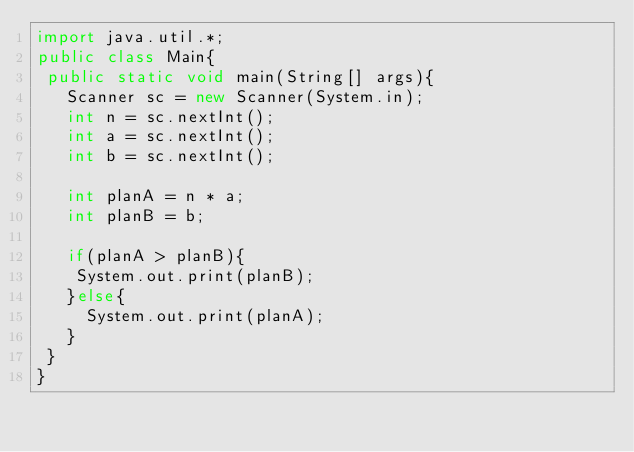Convert code to text. <code><loc_0><loc_0><loc_500><loc_500><_Java_>import java.util.*;
public class Main{
 public static void main(String[] args){
   Scanner sc = new Scanner(System.in);
   int n = sc.nextInt();
   int a = sc.nextInt();
   int b = sc.nextInt();
   
   int planA = n * a;
   int planB = b;
   
   if(planA > planB){
   	System.out.print(planB);
   }else{
     System.out.print(planA);
   }
 }
}</code> 